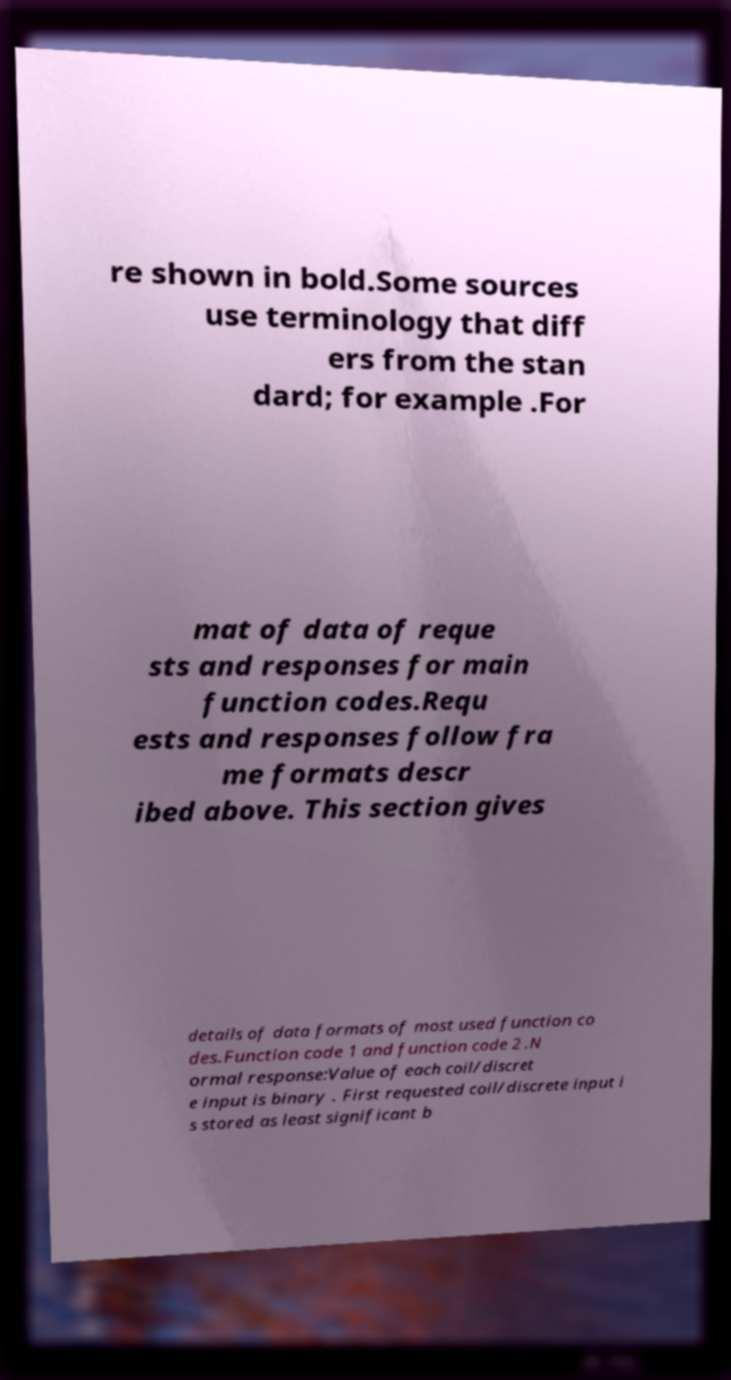Can you accurately transcribe the text from the provided image for me? re shown in bold.Some sources use terminology that diff ers from the stan dard; for example .For mat of data of reque sts and responses for main function codes.Requ ests and responses follow fra me formats descr ibed above. This section gives details of data formats of most used function co des.Function code 1 and function code 2 .N ormal response:Value of each coil/discret e input is binary . First requested coil/discrete input i s stored as least significant b 